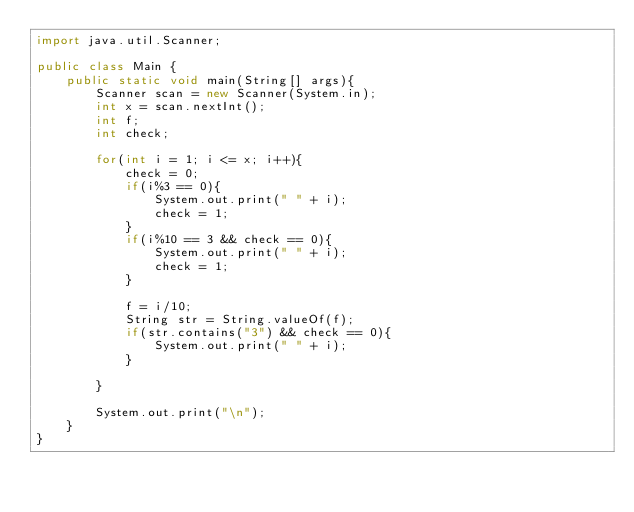Convert code to text. <code><loc_0><loc_0><loc_500><loc_500><_Java_>import java.util.Scanner;

public class Main {
    public static void main(String[] args){
        Scanner scan = new Scanner(System.in);
        int x = scan.nextInt();
        int f;
        int check;

        for(int i = 1; i <= x; i++){
            check = 0;
            if(i%3 == 0){
                System.out.print(" " + i);
                check = 1;
            }
            if(i%10 == 3 && check == 0){
                System.out.print(" " + i);
                check = 1;
            }

            f = i/10;
            String str = String.valueOf(f);
            if(str.contains("3") && check == 0){
                System.out.print(" " + i);
            }

        }

        System.out.print("\n");
    }
}


</code> 